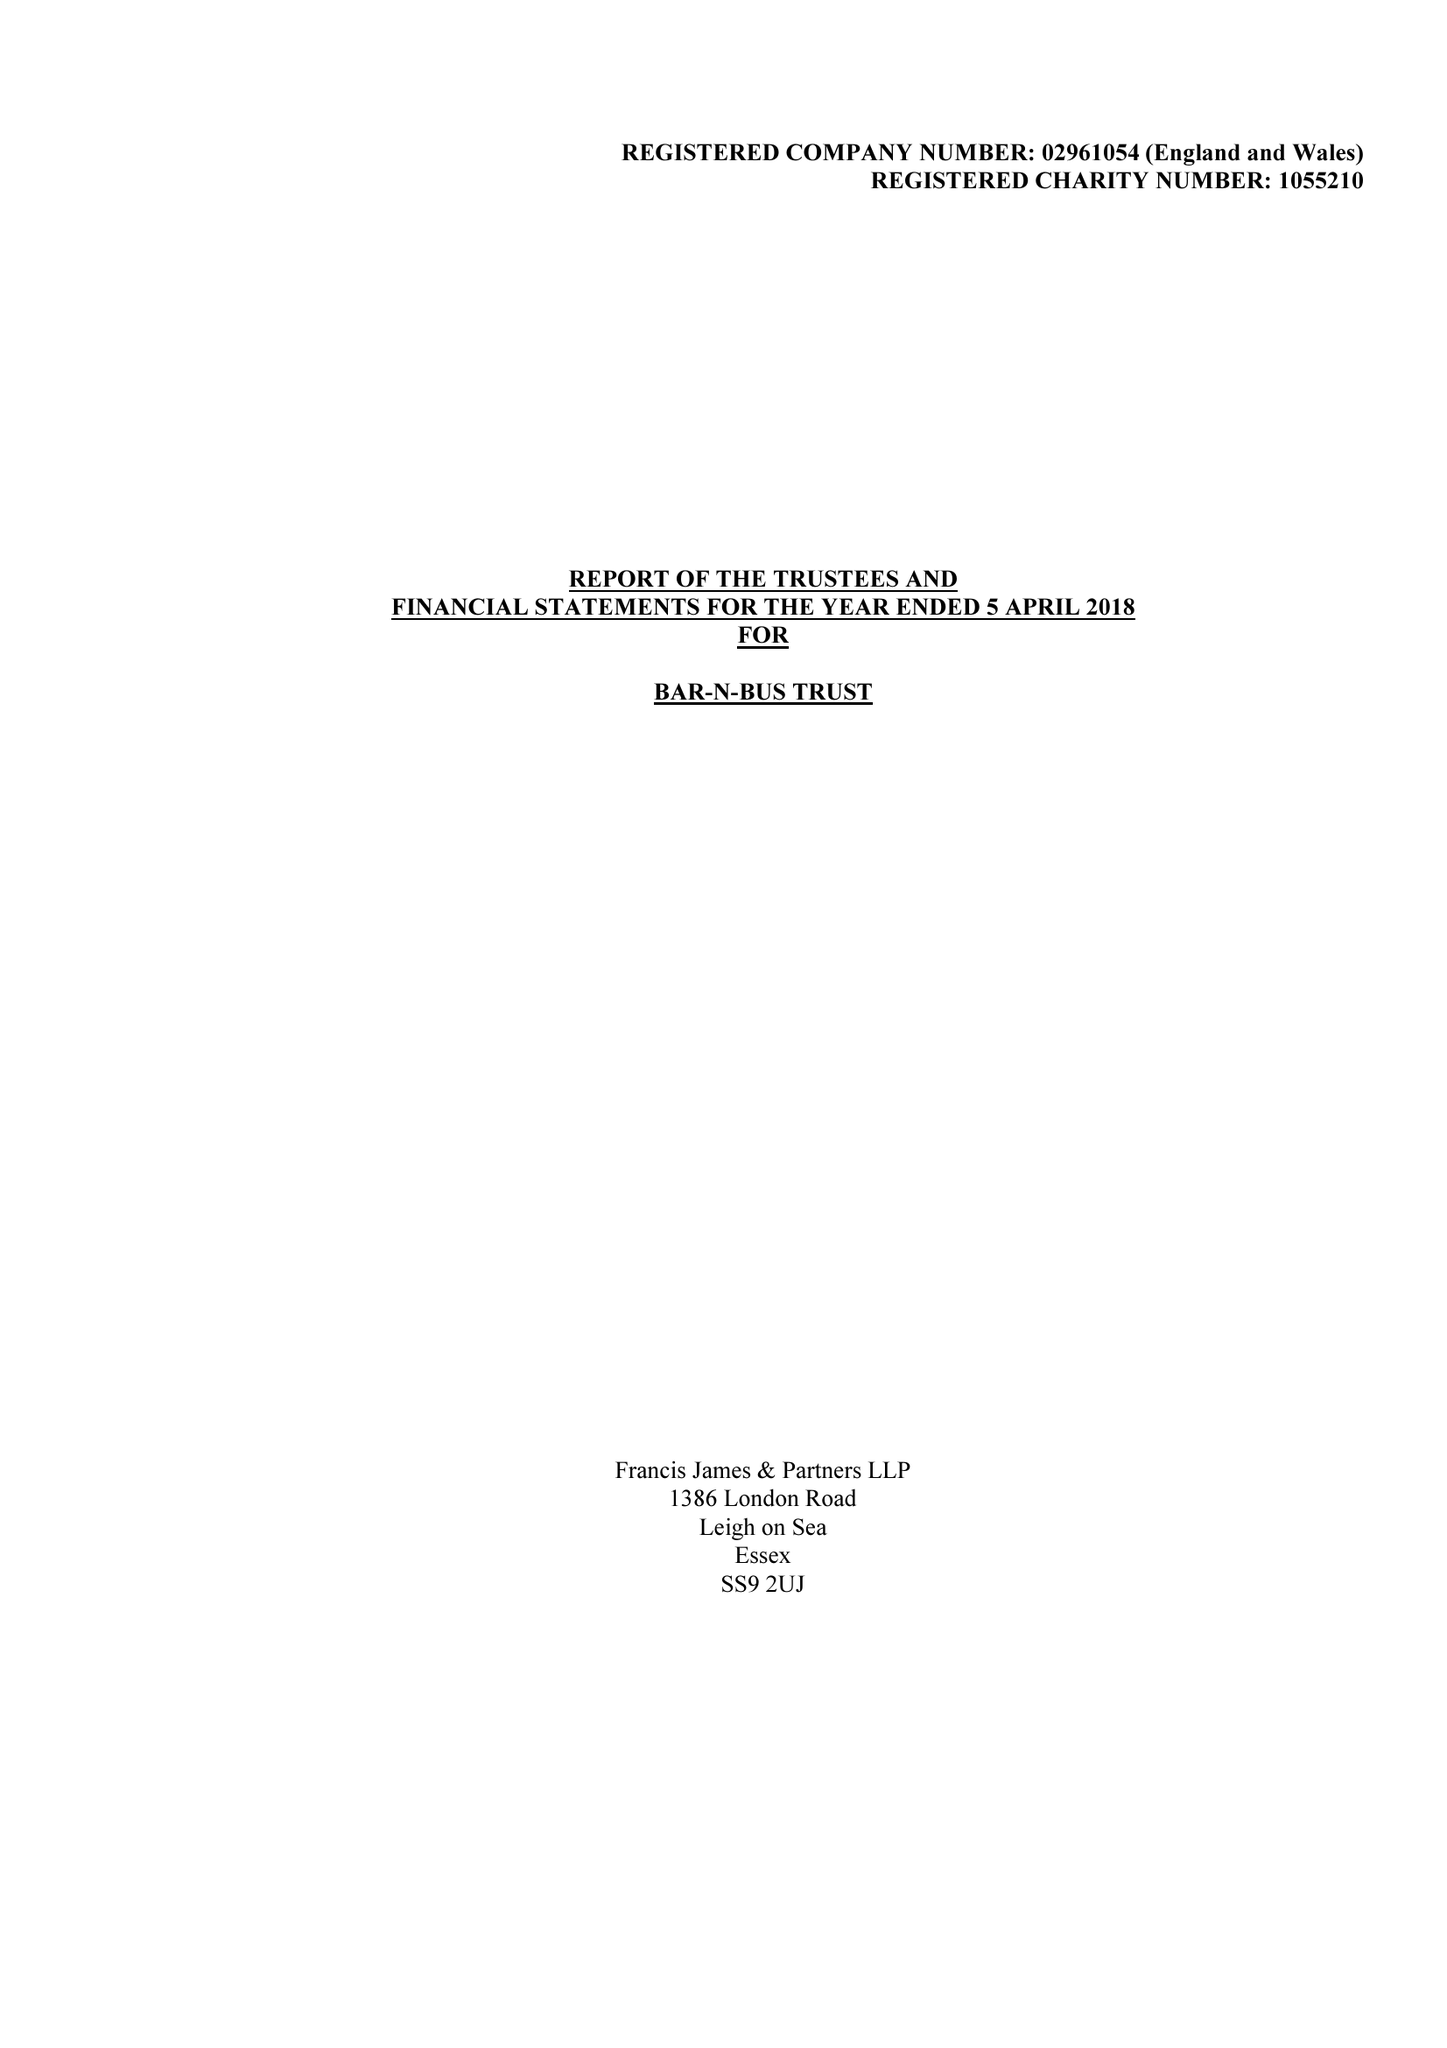What is the value for the report_date?
Answer the question using a single word or phrase. 2018-04-05 